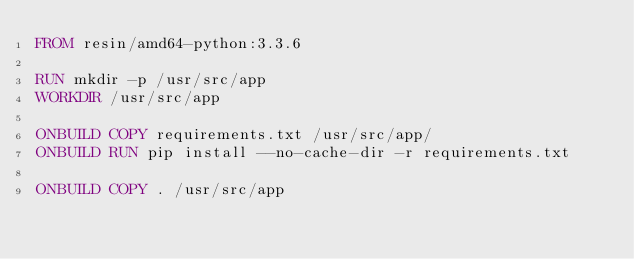<code> <loc_0><loc_0><loc_500><loc_500><_Dockerfile_>FROM resin/amd64-python:3.3.6

RUN mkdir -p /usr/src/app
WORKDIR /usr/src/app

ONBUILD COPY requirements.txt /usr/src/app/
ONBUILD RUN pip install --no-cache-dir -r requirements.txt

ONBUILD COPY . /usr/src/app
</code> 